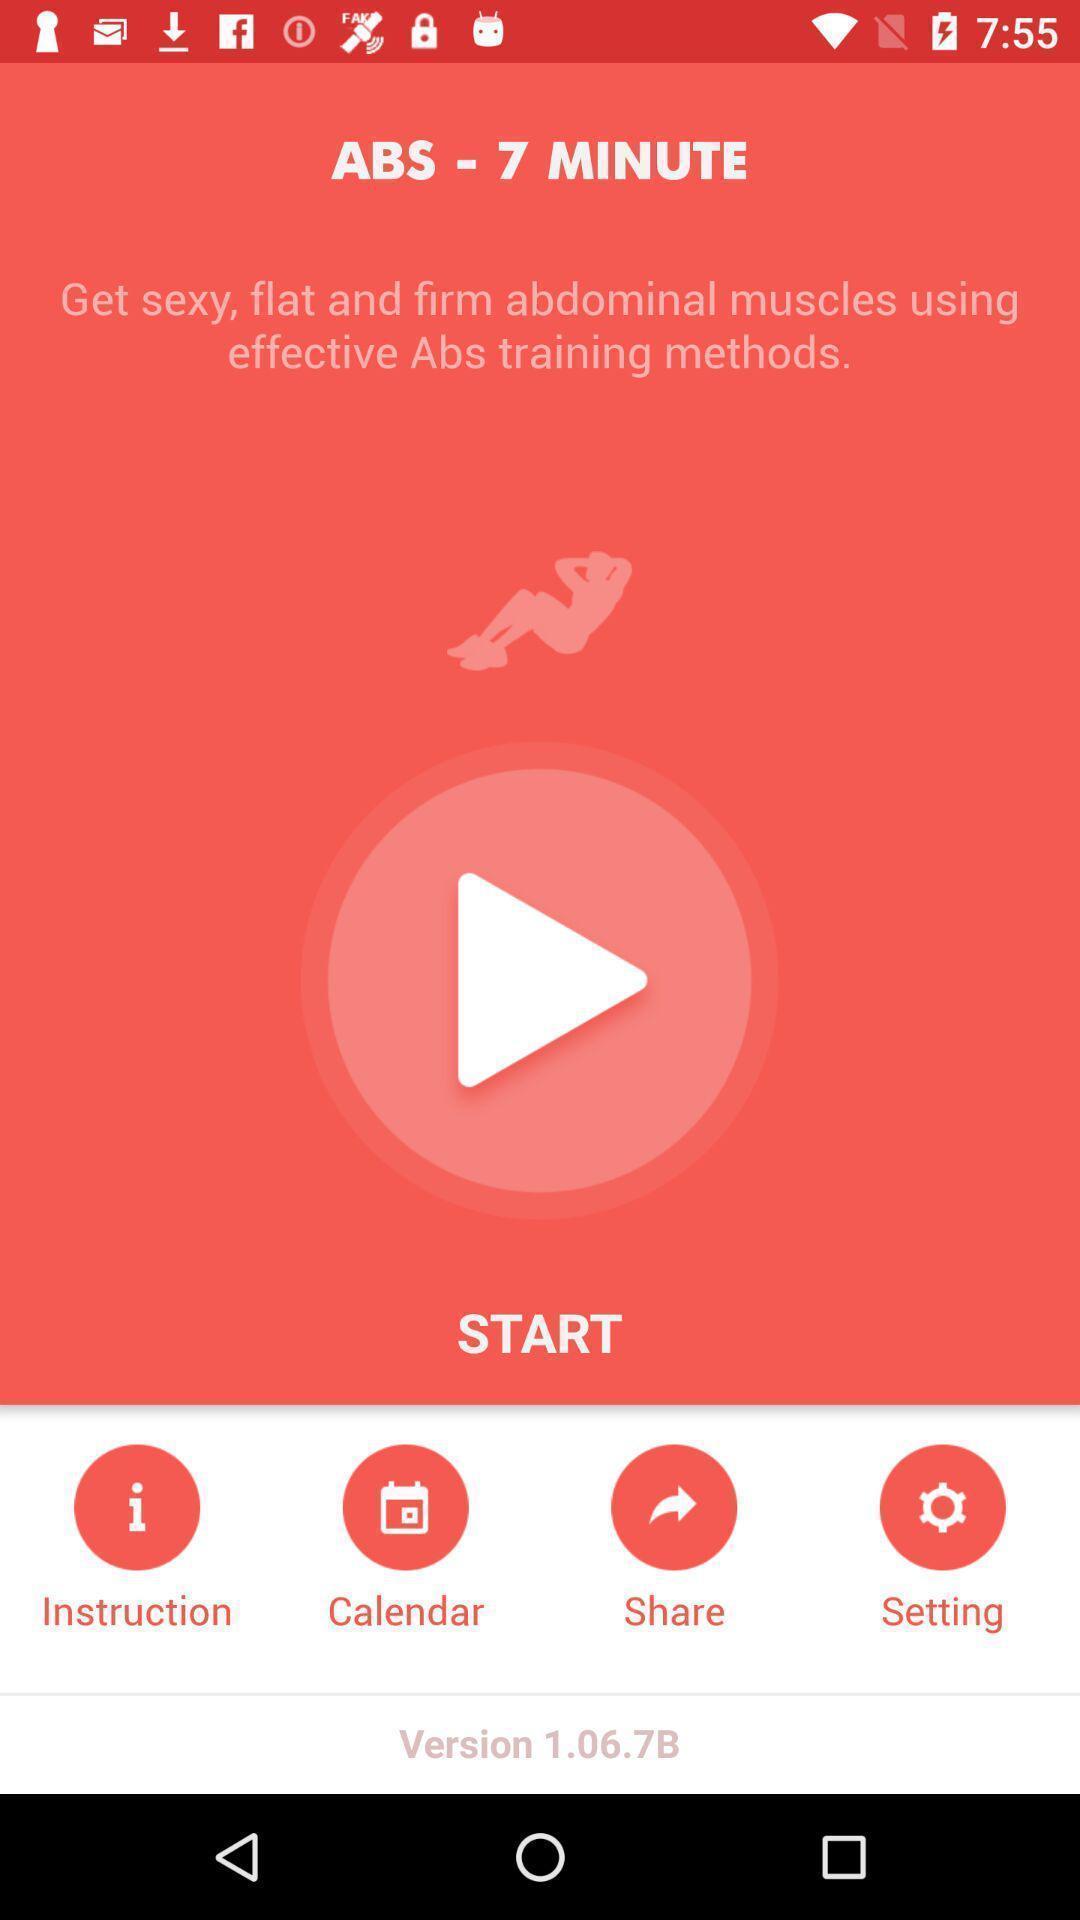Provide a textual representation of this image. Page showing various options in a workout app. 